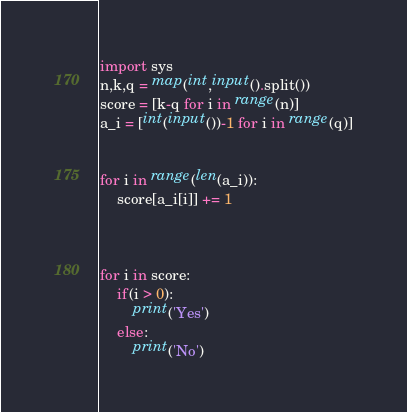<code> <loc_0><loc_0><loc_500><loc_500><_Python_>import sys
n,k,q = map(int,input().split())
score = [k-q for i in range(n)]
a_i = [int(input())-1 for i in range(q)]


for i in range(len(a_i)):
    score[a_i[i]] += 1



for i in score:
    if(i > 0):
        print('Yes')
    else:
        print('No')</code> 